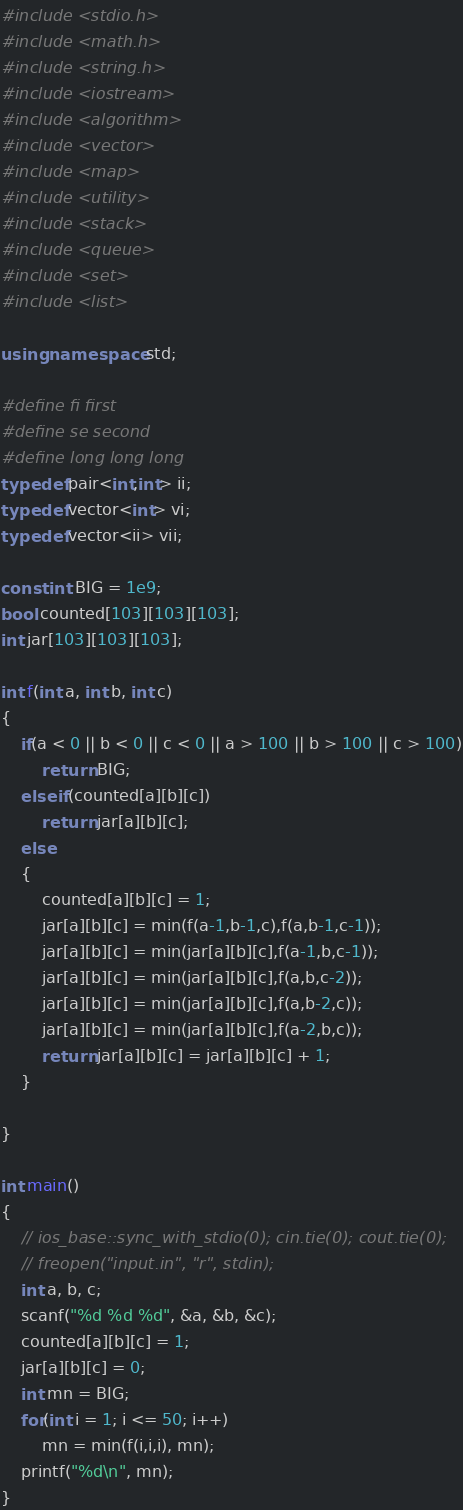<code> <loc_0><loc_0><loc_500><loc_500><_C++_>#include <stdio.h>
#include <math.h>
#include <string.h>
#include <iostream>
#include <algorithm>
#include <vector>
#include <map>
#include <utility>
#include <stack>
#include <queue>
#include <set>
#include <list>

using namespace std;

#define fi first
#define se second
#define long long long
typedef pair<int,int> ii;
typedef vector<int> vi;
typedef vector<ii> vii;

const int BIG = 1e9;
bool counted[103][103][103];
int jar[103][103][103];

int f(int a, int b, int c)
{
	if(a < 0 || b < 0 || c < 0 || a > 100 || b > 100 || c > 100)
		return BIG;
	else if(counted[a][b][c])
		return jar[a][b][c];
	else
	{
		counted[a][b][c] = 1;
		jar[a][b][c] = min(f(a-1,b-1,c),f(a,b-1,c-1));
		jar[a][b][c] = min(jar[a][b][c],f(a-1,b,c-1));
		jar[a][b][c] = min(jar[a][b][c],f(a,b,c-2));
		jar[a][b][c] = min(jar[a][b][c],f(a,b-2,c));
		jar[a][b][c] = min(jar[a][b][c],f(a-2,b,c));
		return jar[a][b][c] = jar[a][b][c] + 1;
	}

}

int main()
{
    // ios_base::sync_with_stdio(0); cin.tie(0); cout.tie(0);
	// freopen("input.in", "r", stdin);
	int a, b, c;
	scanf("%d %d %d", &a, &b, &c);
	counted[a][b][c] = 1;
	jar[a][b][c] = 0;
	int mn = BIG;
	for(int i = 1; i <= 50; i++)
		mn = min(f(i,i,i), mn);
	printf("%d\n", mn);
}



</code> 